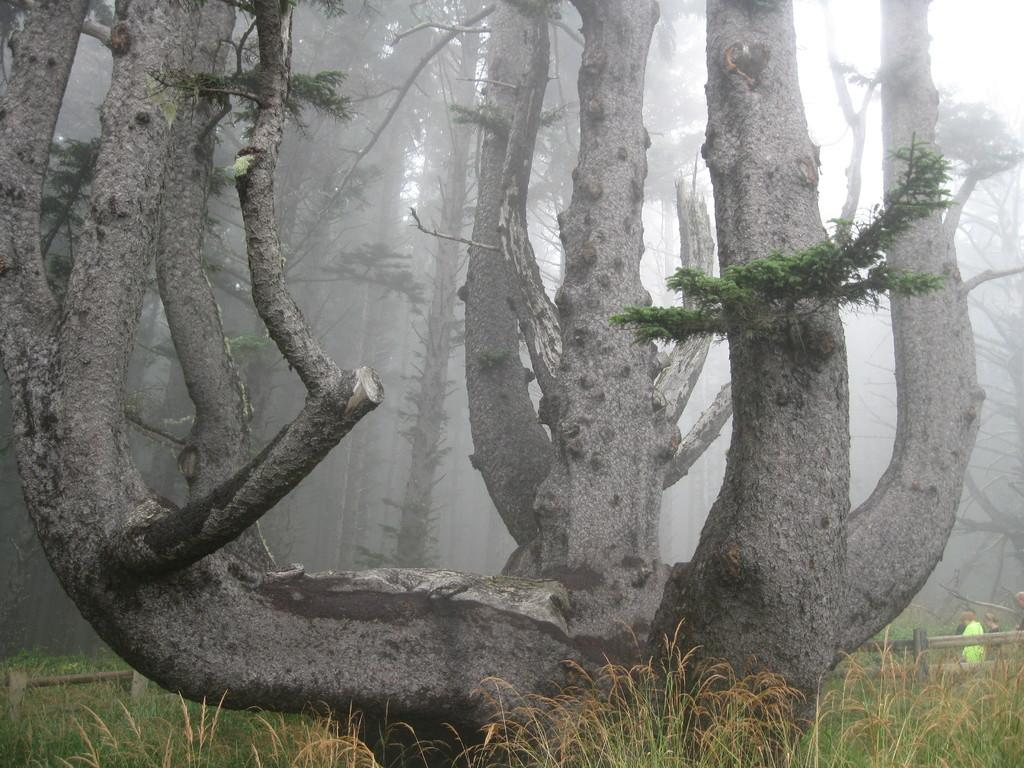What type of vegetation can be seen in the image? There are trees in the image. Can you describe the people in the image? There are people in the image. What is the surface beneath the people and trees? The ground is visible in the image, and there is grass on the ground. What separates the area from another space in the image? There is a fence in the image. What can be seen above the trees and fence in the image? The sky is visible in the image. What hobbies are the people engaged in while wearing trousers in the image? There is no information about the people's hobbies or clothing in the image, so we cannot answer this question. Can you point out the map in the image? There is no map present in the image. 